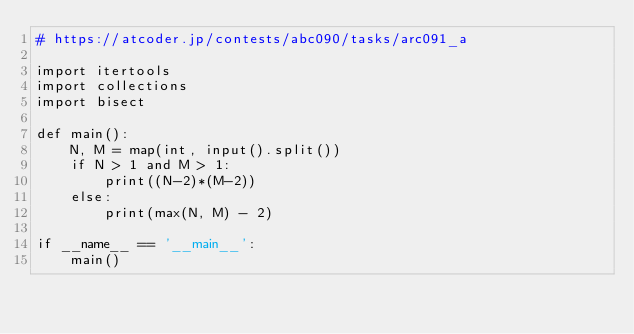Convert code to text. <code><loc_0><loc_0><loc_500><loc_500><_Python_># https://atcoder.jp/contests/abc090/tasks/arc091_a

import itertools
import collections
import bisect

def main():
    N, M = map(int, input().split())
    if N > 1 and M > 1:
        print((N-2)*(M-2))
    else:
        print(max(N, M) - 2)

if __name__ == '__main__':
    main()
</code> 